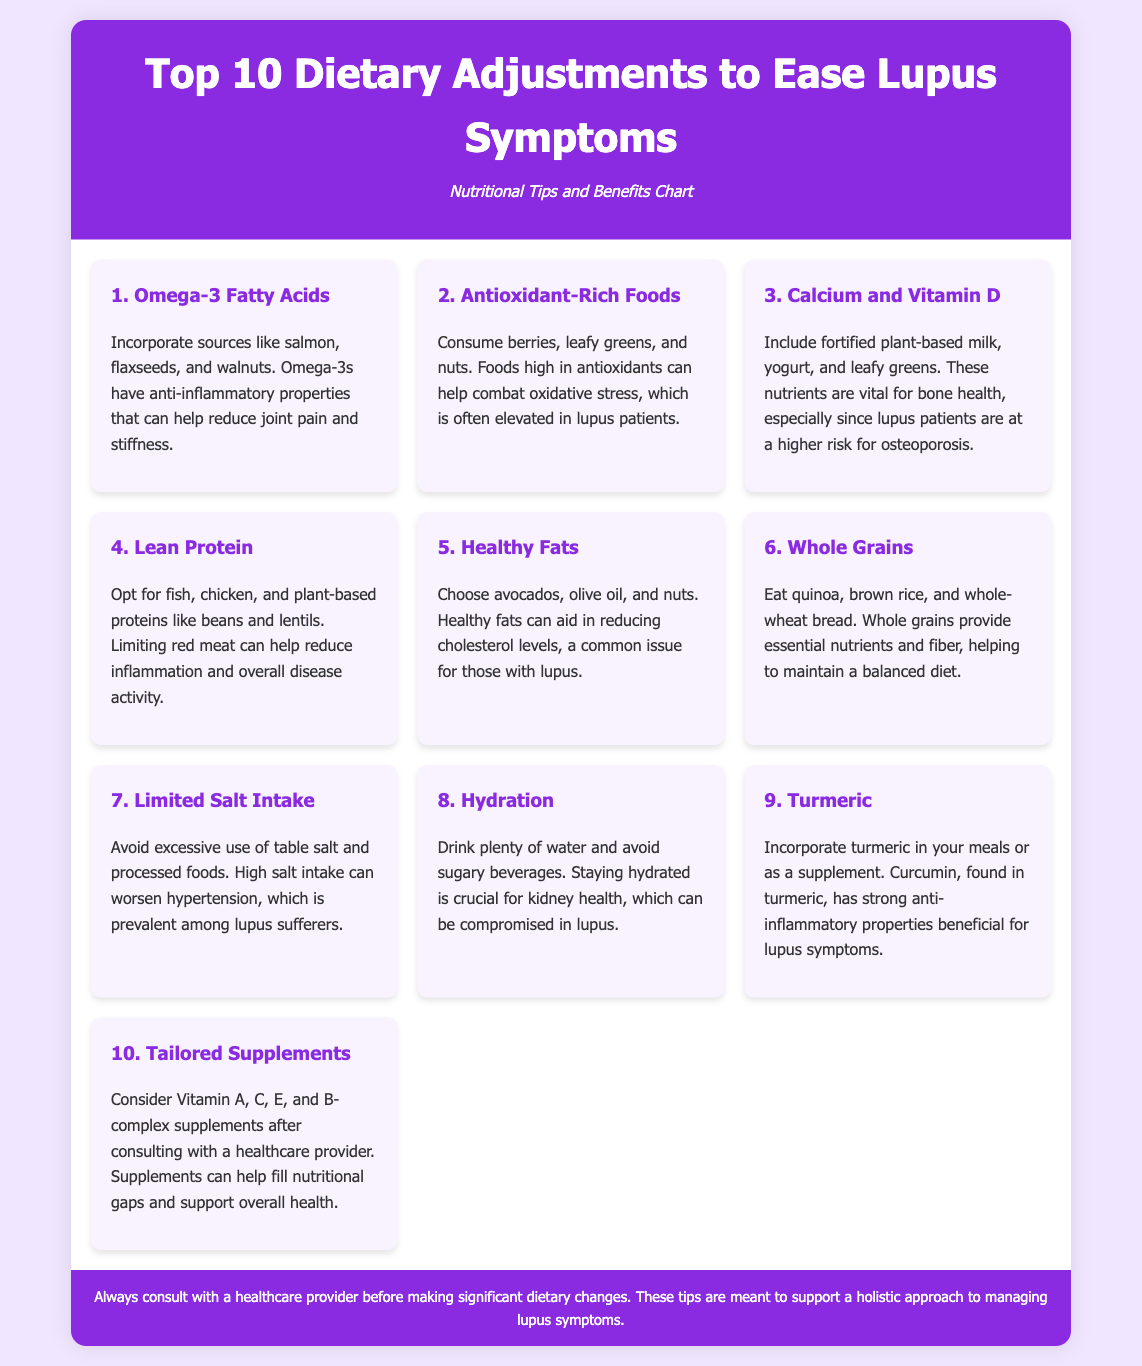What is the title of the document? The title indicates the main topic of the infographic, which is presented prominently at the top.
Answer: Top 10 Dietary Adjustments to Ease Lupus Symptoms What are the benefits of Omega-3 fatty acids? The document states that Omega-3s have anti-inflammatory properties to help reduce joint pain and stiffness.
Answer: Anti-inflammatory properties Which food is suggested for hydration? The document specifies water as a key beverage to maintain hydration.
Answer: Water How many dietary adjustments are listed in the infographic? The primary heading indicates the total number of dietary adjustments covered in the document.
Answer: 10 What is a suggested source of lean protein? The document provides specific examples of lean protein sources that are beneficial for lupus patients.
Answer: Fish What is the importance of Calcium and Vitamin D for lupus patients? The document explains these nutrients are vital for bone health, especially for those at higher risk for osteoporosis.
Answer: Bone health What ingredient in turmeric is mentioned for its properties? The document highlights curcumin as the active component of turmeric with benefits for lupus symptoms.
Answer: Curcumin What dietary adjustment is associated with limited salt intake? The document discusses avoiding excessive use of table salt and processed foods to help manage hypertension.
Answer: High salt intake What should one consider before taking supplements? The document recommends consulting with a healthcare provider before making significant dietary changes.
Answer: Healthcare provider 